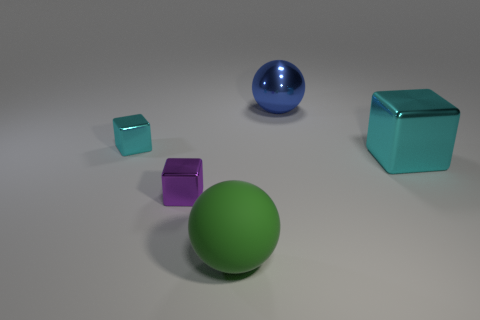Add 5 cyan metal objects. How many objects exist? 10 Subtract all balls. How many objects are left? 3 Add 2 green matte objects. How many green matte objects are left? 3 Add 1 green spheres. How many green spheres exist? 2 Subtract 0 brown blocks. How many objects are left? 5 Subtract all metal things. Subtract all green metallic blocks. How many objects are left? 1 